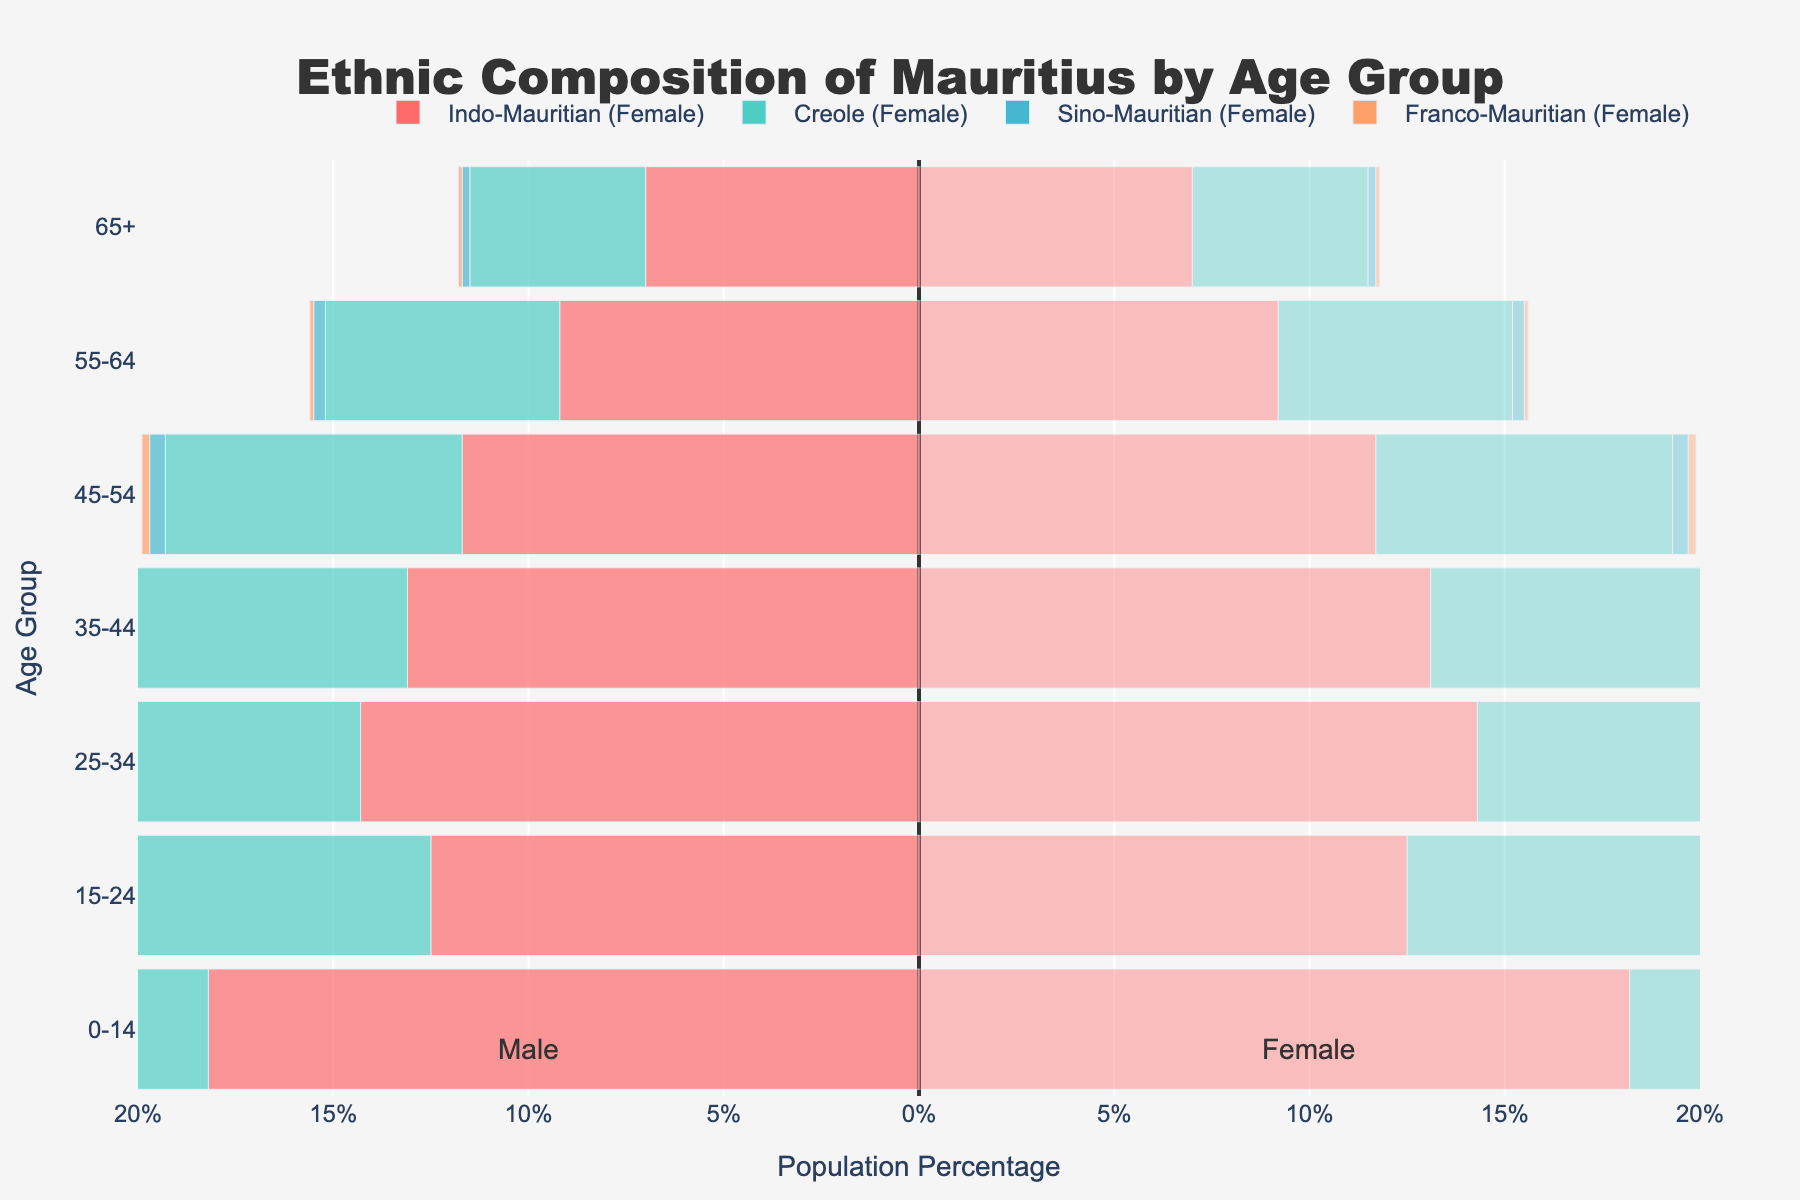What is the title of the figure? The title of the figure is located at the top and describes the content of the graph. It states, "Ethnic Composition of Mauritius by Age Group".
Answer: Ethnic Composition of Mauritius by Age Group Which ethnic group has the highest population percentage in the 25-34 age group? The bars representing the age group 25-34 show the highest values for Indo-Mauritian as compared to Creole, Sino-Mauritian, and Franco-Mauritian.
Answer: Indo-Mauritian Compare the population percentages of Creoles and Franco-Mauritians in the 45-54 age group. By examining the bars for the 45-54 age group, Creoles have a bar extending to 7.6%, while Franco-Mauritians extend to 0.2%. Thus, Creoles have a larger population percentage than Franco-Mauritians in this age group.
Answer: Creoles have a larger population percentage How does the percentage of Sino-Mauritians in the 65+ age group compare to those in the 55-64 age group? We observe that the population percentage for Sino-Mauritians in the 65+ age group is 0.2%, while in the 55-64 age group, it is 0.3%.
Answer: Lower in 65+ age group What is the total population percentage for Creoles across all age groups? Adding up the percentages for Creoles in each age group: 11.8 + 8.1 + 9.3 + 8.5 + 7.6 + 6.0 + 4.5 = 55.8. Therefore, the total population percentage for Creoles across all age groups is 55.8%.
Answer: 55.8% Which age group has the smallest percentage of Indo-Mauritians? By comparing the Indo-Mauritian bars across all age groups, the 65+ age group has the smallest percentage at 7.0%.
Answer: 65+ What is the combined percentage of Indo-Mauritians and Creoles in the 0-14 age group? Adding the percentages for Indo-Mauritians and Creoles in the 0-14 age group: 18.2 + 11.8 = 30.0%.
Answer: 30.0% How does the population percentage of Franco-Mauritians change from the 35-44 age group to the 65+ age group? Observing the bars for Franco-Mauritians, the 35-44 age group shows 0.2%, and the 65+ age group also shows 0.1%. Since 0.1% is half of 0.2%, the percentage decreased by 0.1%.
Answer: Decreased by 0.1% What is the most significant age group for Sino-Mauritians? The highest bar for Sino-Mauritians appears in the 0-14 age group at 0.7%.
Answer: 0-14 